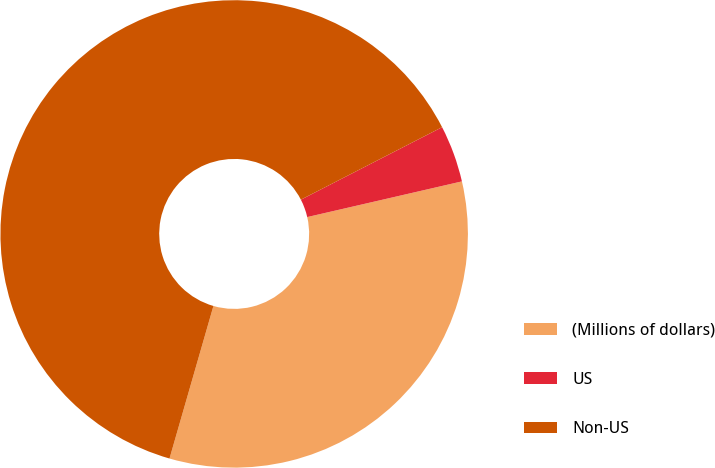Convert chart to OTSL. <chart><loc_0><loc_0><loc_500><loc_500><pie_chart><fcel>(Millions of dollars)<fcel>US<fcel>Non-US<nl><fcel>33.07%<fcel>3.94%<fcel>62.99%<nl></chart> 